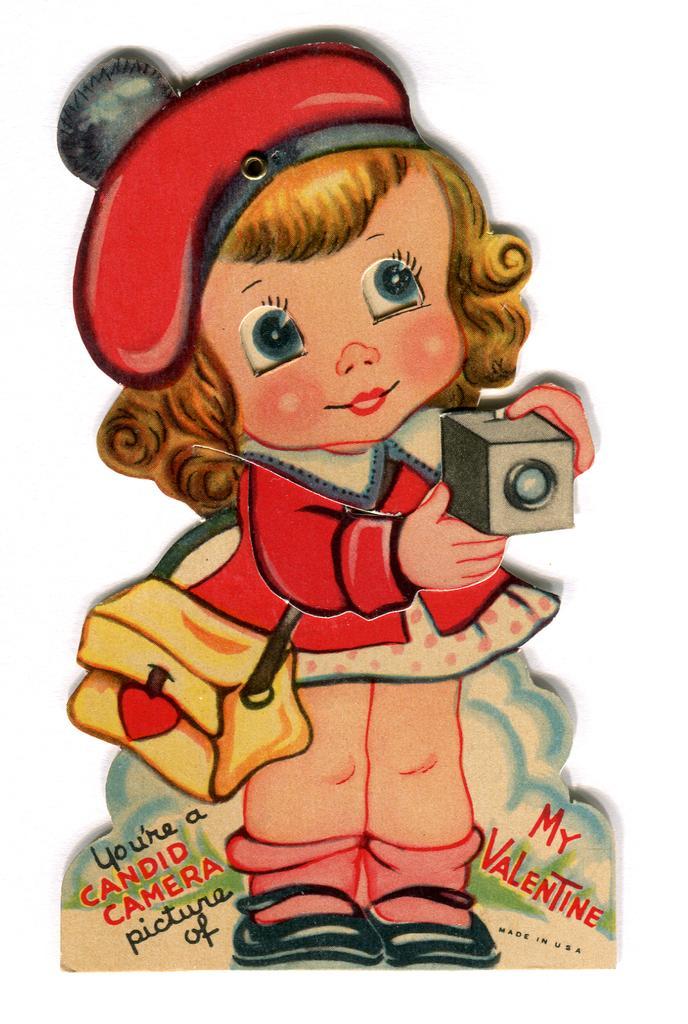Please provide a concise description of this image. In this image I can see a baby girl wearing red and cream colored dress is standing and holding an object in her hand. I can see she is wearing red colored hat and cream colored bag. I can see the white colored background. 